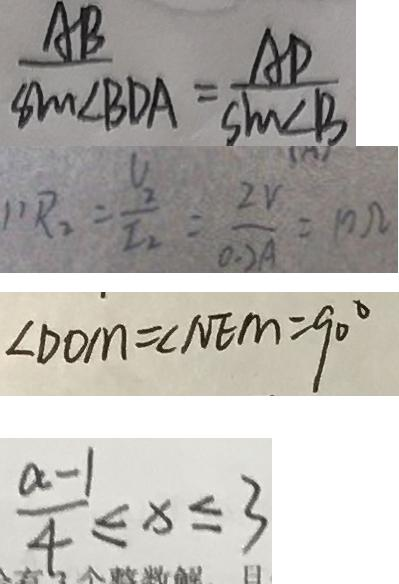<formula> <loc_0><loc_0><loc_500><loc_500>\frac { A B } { \sin \angle B D A } = \frac { A D } { \sin \angle B } 
 1 ) R _ { 2 } = \frac { U 2 } { I _ { 2 } } = \frac { 2 v } { 0 . 2 A } = 1 0 \Omega 
 \angle D O M = \angle N E M = 9 0 ^ { \circ } 
 \frac { a - 1 } { 4 } \leq x \leq 3</formula> 